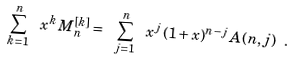<formula> <loc_0><loc_0><loc_500><loc_500>\sum _ { k = 1 } ^ { n } \ x ^ { k } \, M _ { n } ^ { [ k ] } = \ \sum _ { j = 1 } ^ { n } \ x ^ { j } \, ( 1 + x ) ^ { n - j } \, { A } ( n , j ) \ .</formula> 